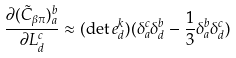<formula> <loc_0><loc_0><loc_500><loc_500>\frac { \partial ( \tilde { C } _ { \beta \pi } ) ^ { b } _ { a } } { \partial L ^ { c } _ { d } } \approx ( \det e ^ { k } _ { d } ) ( \delta ^ { c } _ { a } \delta ^ { b } _ { d } - \frac { 1 } { 3 } \delta ^ { b } _ { a } \delta ^ { c } _ { d } )</formula> 